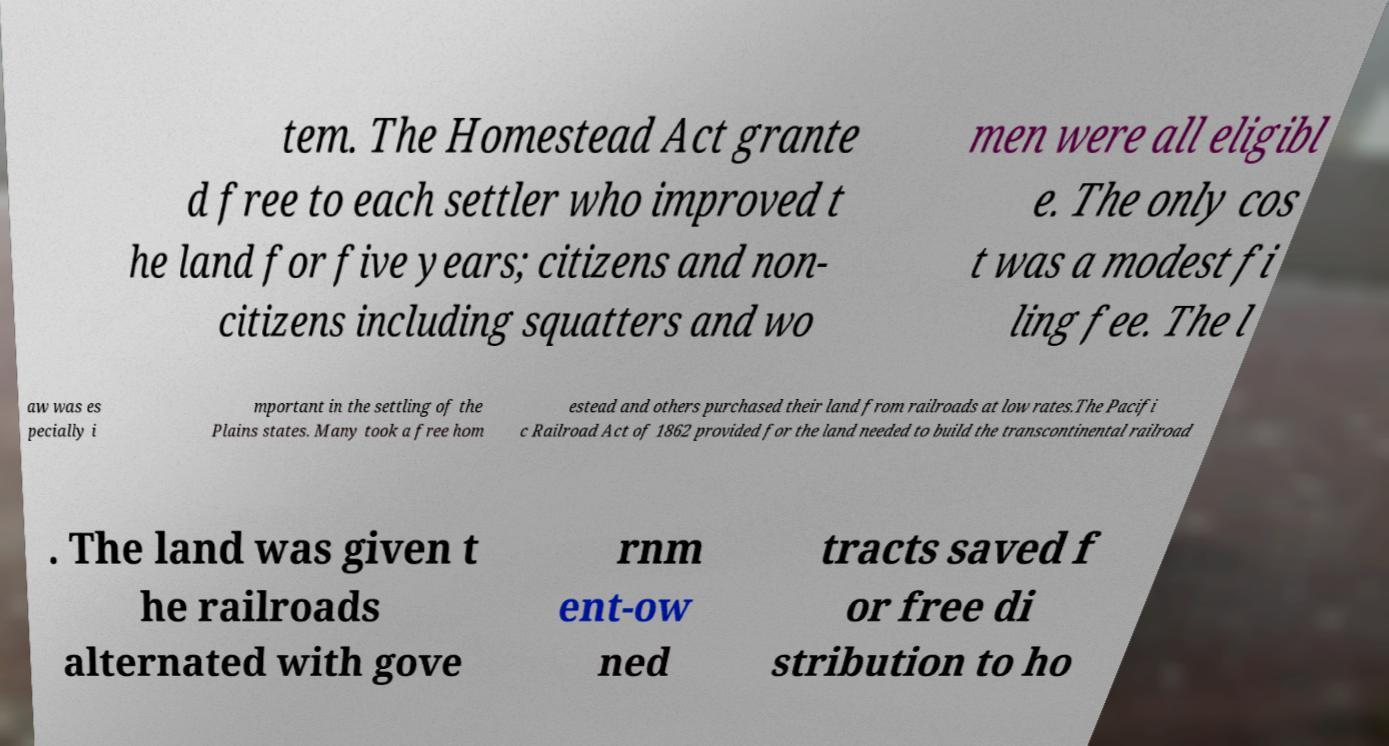Can you read and provide the text displayed in the image?This photo seems to have some interesting text. Can you extract and type it out for me? tem. The Homestead Act grante d free to each settler who improved t he land for five years; citizens and non- citizens including squatters and wo men were all eligibl e. The only cos t was a modest fi ling fee. The l aw was es pecially i mportant in the settling of the Plains states. Many took a free hom estead and others purchased their land from railroads at low rates.The Pacifi c Railroad Act of 1862 provided for the land needed to build the transcontinental railroad . The land was given t he railroads alternated with gove rnm ent-ow ned tracts saved f or free di stribution to ho 